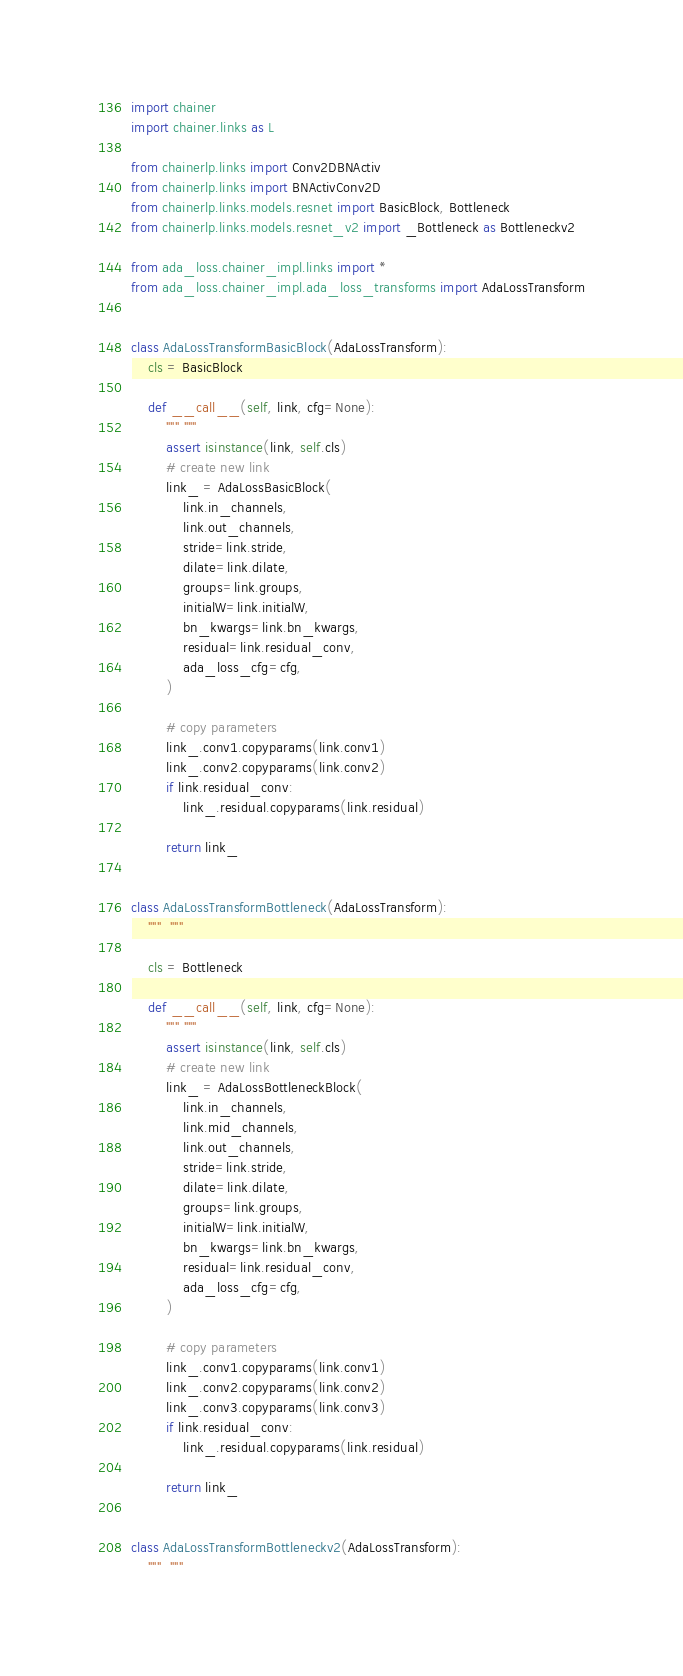Convert code to text. <code><loc_0><loc_0><loc_500><loc_500><_Python_>import chainer
import chainer.links as L

from chainerlp.links import Conv2DBNActiv
from chainerlp.links import BNActivConv2D
from chainerlp.links.models.resnet import BasicBlock, Bottleneck
from chainerlp.links.models.resnet_v2 import _Bottleneck as Bottleneckv2

from ada_loss.chainer_impl.links import *
from ada_loss.chainer_impl.ada_loss_transforms import AdaLossTransform


class AdaLossTransformBasicBlock(AdaLossTransform):
    cls = BasicBlock

    def __call__(self, link, cfg=None):
        """ """
        assert isinstance(link, self.cls)
        # create new link
        link_ = AdaLossBasicBlock(
            link.in_channels,
            link.out_channels,
            stride=link.stride,
            dilate=link.dilate,
            groups=link.groups,
            initialW=link.initialW,
            bn_kwargs=link.bn_kwargs,
            residual=link.residual_conv,
            ada_loss_cfg=cfg,
        )

        # copy parameters
        link_.conv1.copyparams(link.conv1)
        link_.conv2.copyparams(link.conv2)
        if link.residual_conv:
            link_.residual.copyparams(link.residual)

        return link_


class AdaLossTransformBottleneck(AdaLossTransform):
    """  """

    cls = Bottleneck

    def __call__(self, link, cfg=None):
        """ """
        assert isinstance(link, self.cls)
        # create new link
        link_ = AdaLossBottleneckBlock(
            link.in_channels,
            link.mid_channels,
            link.out_channels,
            stride=link.stride,
            dilate=link.dilate,
            groups=link.groups,
            initialW=link.initialW,
            bn_kwargs=link.bn_kwargs,
            residual=link.residual_conv,
            ada_loss_cfg=cfg,
        )

        # copy parameters
        link_.conv1.copyparams(link.conv1)
        link_.conv2.copyparams(link.conv2)
        link_.conv3.copyparams(link.conv3)
        if link.residual_conv:
            link_.residual.copyparams(link.residual)

        return link_


class AdaLossTransformBottleneckv2(AdaLossTransform):
    """  """
</code> 